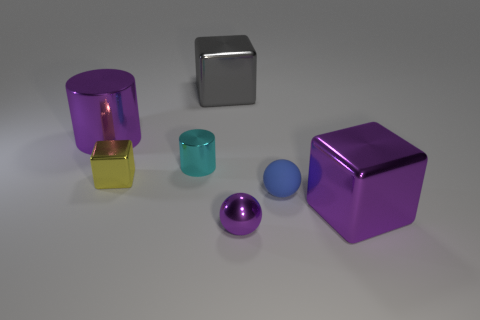Are there more purple things than tiny yellow objects?
Make the answer very short. Yes. What is the size of the thing that is right of the big metal cylinder and behind the tiny cyan metallic object?
Offer a terse response. Large. There is a small sphere that is the same color as the big cylinder; what material is it?
Your answer should be very brief. Metal. Are there an equal number of purple balls that are on the left side of the small cyan metallic cylinder and gray metal things?
Give a very brief answer. No. Is the size of the gray cube the same as the yellow object?
Provide a succinct answer. No. There is a large metallic thing that is both right of the large purple metallic cylinder and in front of the gray metal cube; what color is it?
Your answer should be very brief. Purple. What is the material of the large object behind the big shiny object on the left side of the big gray cube?
Give a very brief answer. Metal. What size is the gray object that is the same shape as the yellow object?
Make the answer very short. Large. Is the color of the metal cube that is right of the big gray metallic block the same as the metal sphere?
Make the answer very short. Yes. Is the number of tiny yellow shiny objects less than the number of large cubes?
Your response must be concise. Yes. 